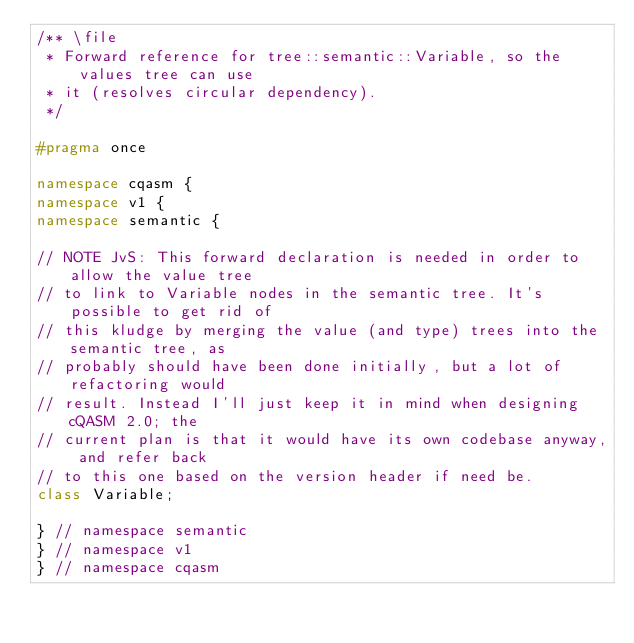Convert code to text. <code><loc_0><loc_0><loc_500><loc_500><_C++_>/** \file
 * Forward reference for tree::semantic::Variable, so the values tree can use
 * it (resolves circular dependency).
 */

#pragma once

namespace cqasm {
namespace v1 {
namespace semantic {

// NOTE JvS: This forward declaration is needed in order to allow the value tree
// to link to Variable nodes in the semantic tree. It's possible to get rid of
// this kludge by merging the value (and type) trees into the semantic tree, as
// probably should have been done initially, but a lot of refactoring would
// result. Instead I'll just keep it in mind when designing cQASM 2.0; the
// current plan is that it would have its own codebase anyway, and refer back
// to this one based on the version header if need be.
class Variable;

} // namespace semantic
} // namespace v1
} // namespace cqasm
</code> 